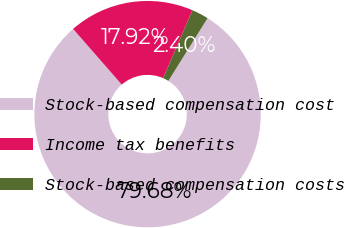Convert chart. <chart><loc_0><loc_0><loc_500><loc_500><pie_chart><fcel>Stock-based compensation cost<fcel>Income tax benefits<fcel>Stock-based compensation costs<nl><fcel>79.68%<fcel>17.92%<fcel>2.4%<nl></chart> 